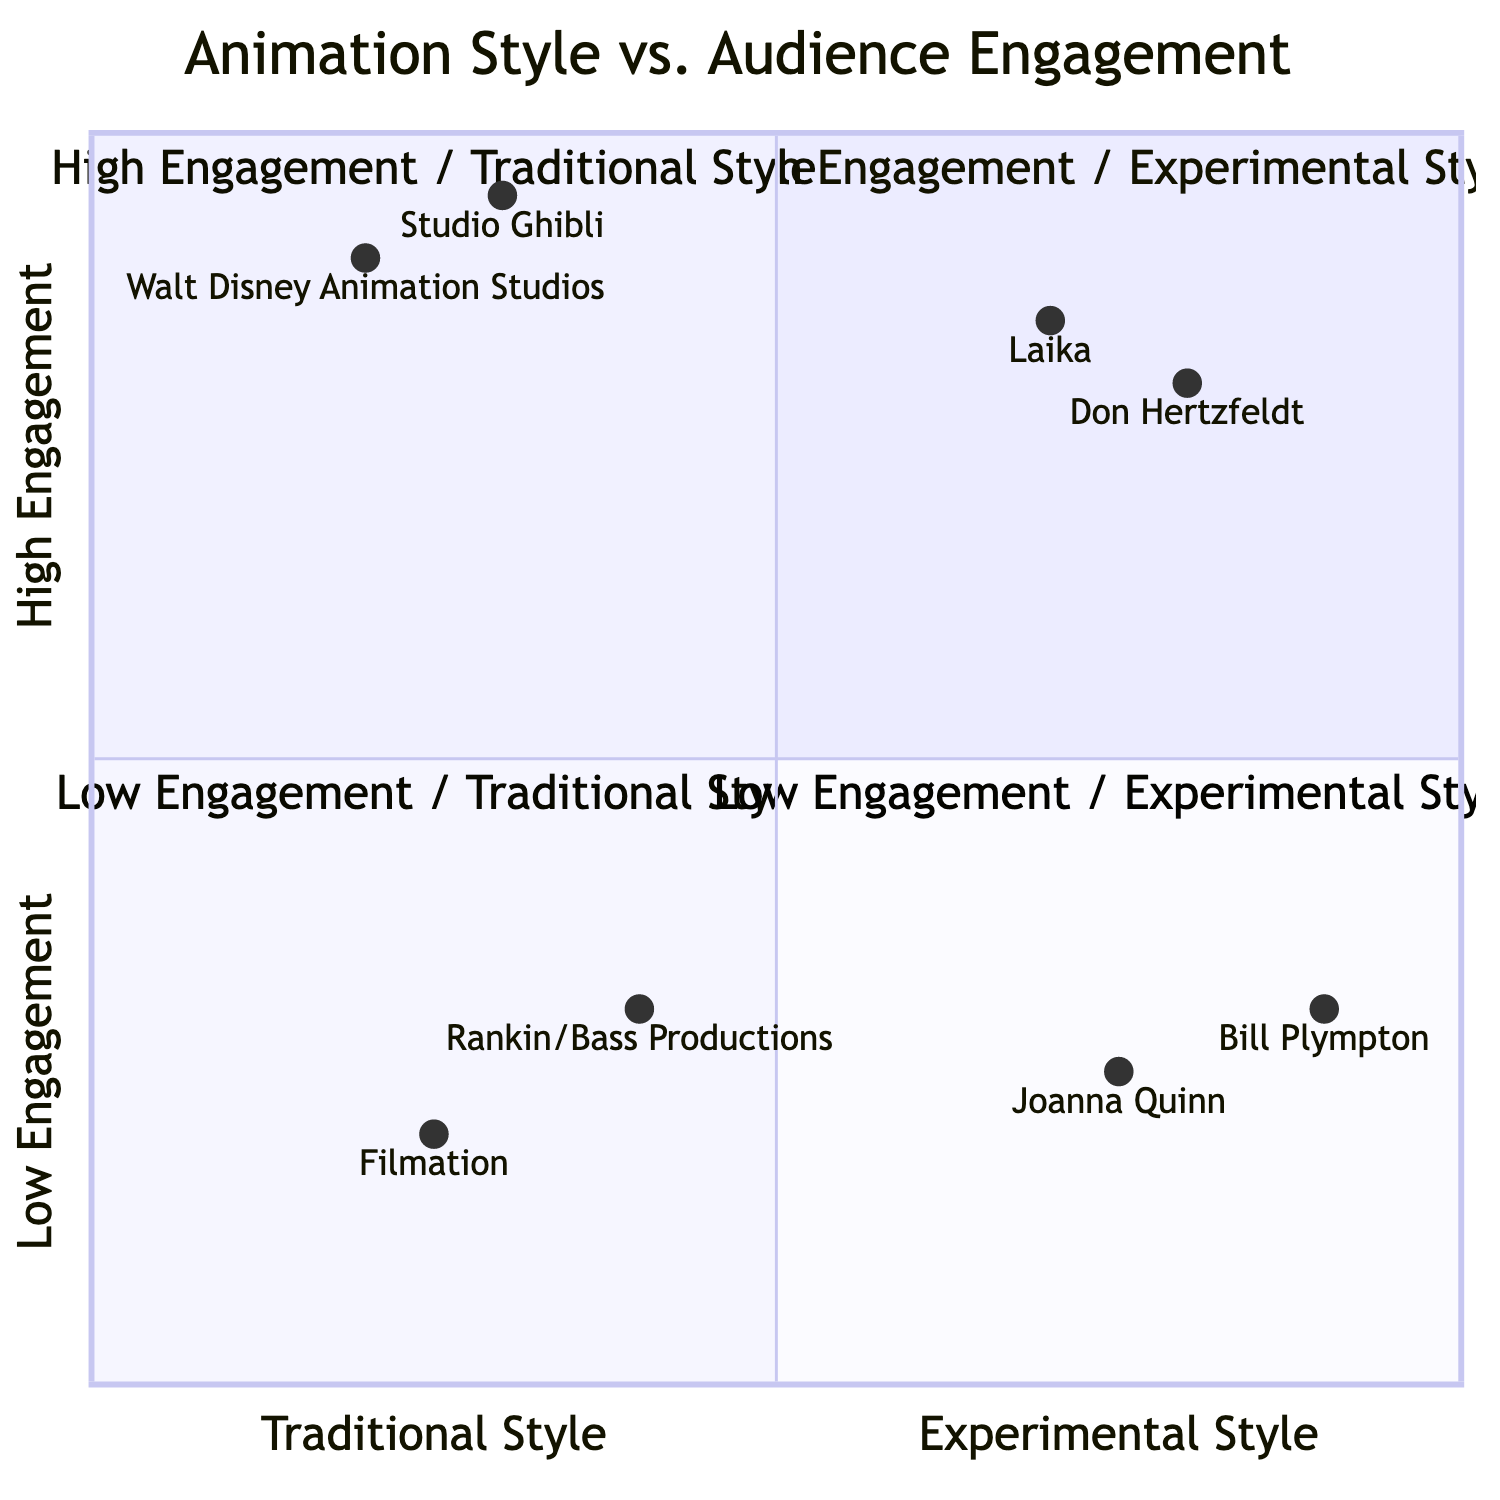What two studios are in the High Engagement / Traditional Style quadrant? The High Engagement / Traditional Style quadrant includes Walt Disney Animation Studios and Studio Ghibli, which are both renowned for their classic hand-drawn films.
Answer: Walt Disney Animation Studios, Studio Ghibli What is the engagement level of Rankin/Bass Productions? Rankin/Bass Productions is located in the Low Engagement / Traditional Style quadrant, indicating a lower level of audience engagement compared to the others.
Answer: Low Engagement Which studio is in the High Engagement / Experimental Style quadrant? Laika and Don Hertzfeldt are both located in the High Engagement / Experimental Style quadrant, indicating that they engage audiences significantly through their unique animation styles.
Answer: Laika, Don Hertzfeldt Which studio has the highest engagement level according to the chart? The highest engagement level is found in the High Engagement / Traditional Style quadrant, specifically with Studio Ghibli at 0.95 on the y-axis, indicating very high engagement.
Answer: Studio Ghibli What is the specific style of Joanna Quinn's animations? Joanna Quinn is known for creating hand-drawn animated shorts, indicating a focus on traditional styles with a unique flavor.
Answer: Hand-drawn animated shorts What trend is observed in the Low Engagement / Experimental Style quadrant? The Low Engagement / Experimental Style quadrant contains Bill Plympton and Joanna Quinn, indicating that experimental styles may engage niche audiences but struggle with broader appeal.
Answer: Niche appeal How many total studios are located in the High Engagement quadrants? There are four studios located in the High Engagement quadrants, specifically two in High Engagement / Traditional Style and two in High Engagement / Experimental Style.
Answer: Four studios What is the y-axis value for Laika? Laika is positioned at a y-axis value of 0.85, representing its high level of audience engagement in the High Engagement / Experimental Style quadrant.
Answer: 0.85 